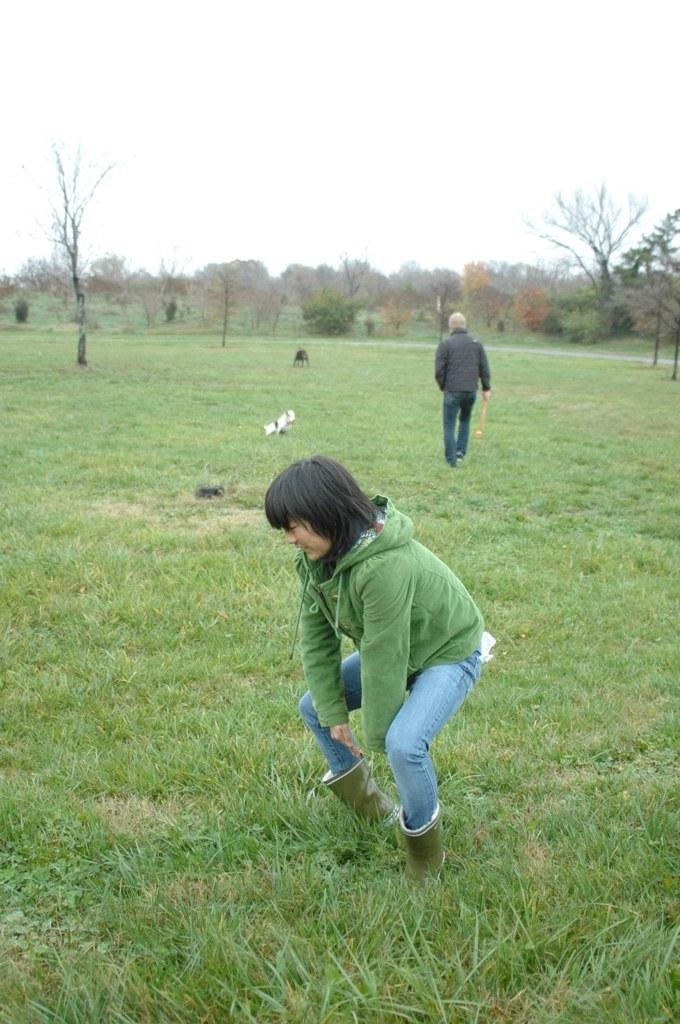What is the woman in the image doing? The woman is in a squat position on the grass. Where is the woman located in the image? The woman is on the ground. What can be seen in the background of the image? There is a dog, a man walking on the grass, trees, and the sky visible in the background. What type of request is the farmer making to the mine in the image? There is no farmer or mine present in the image. 